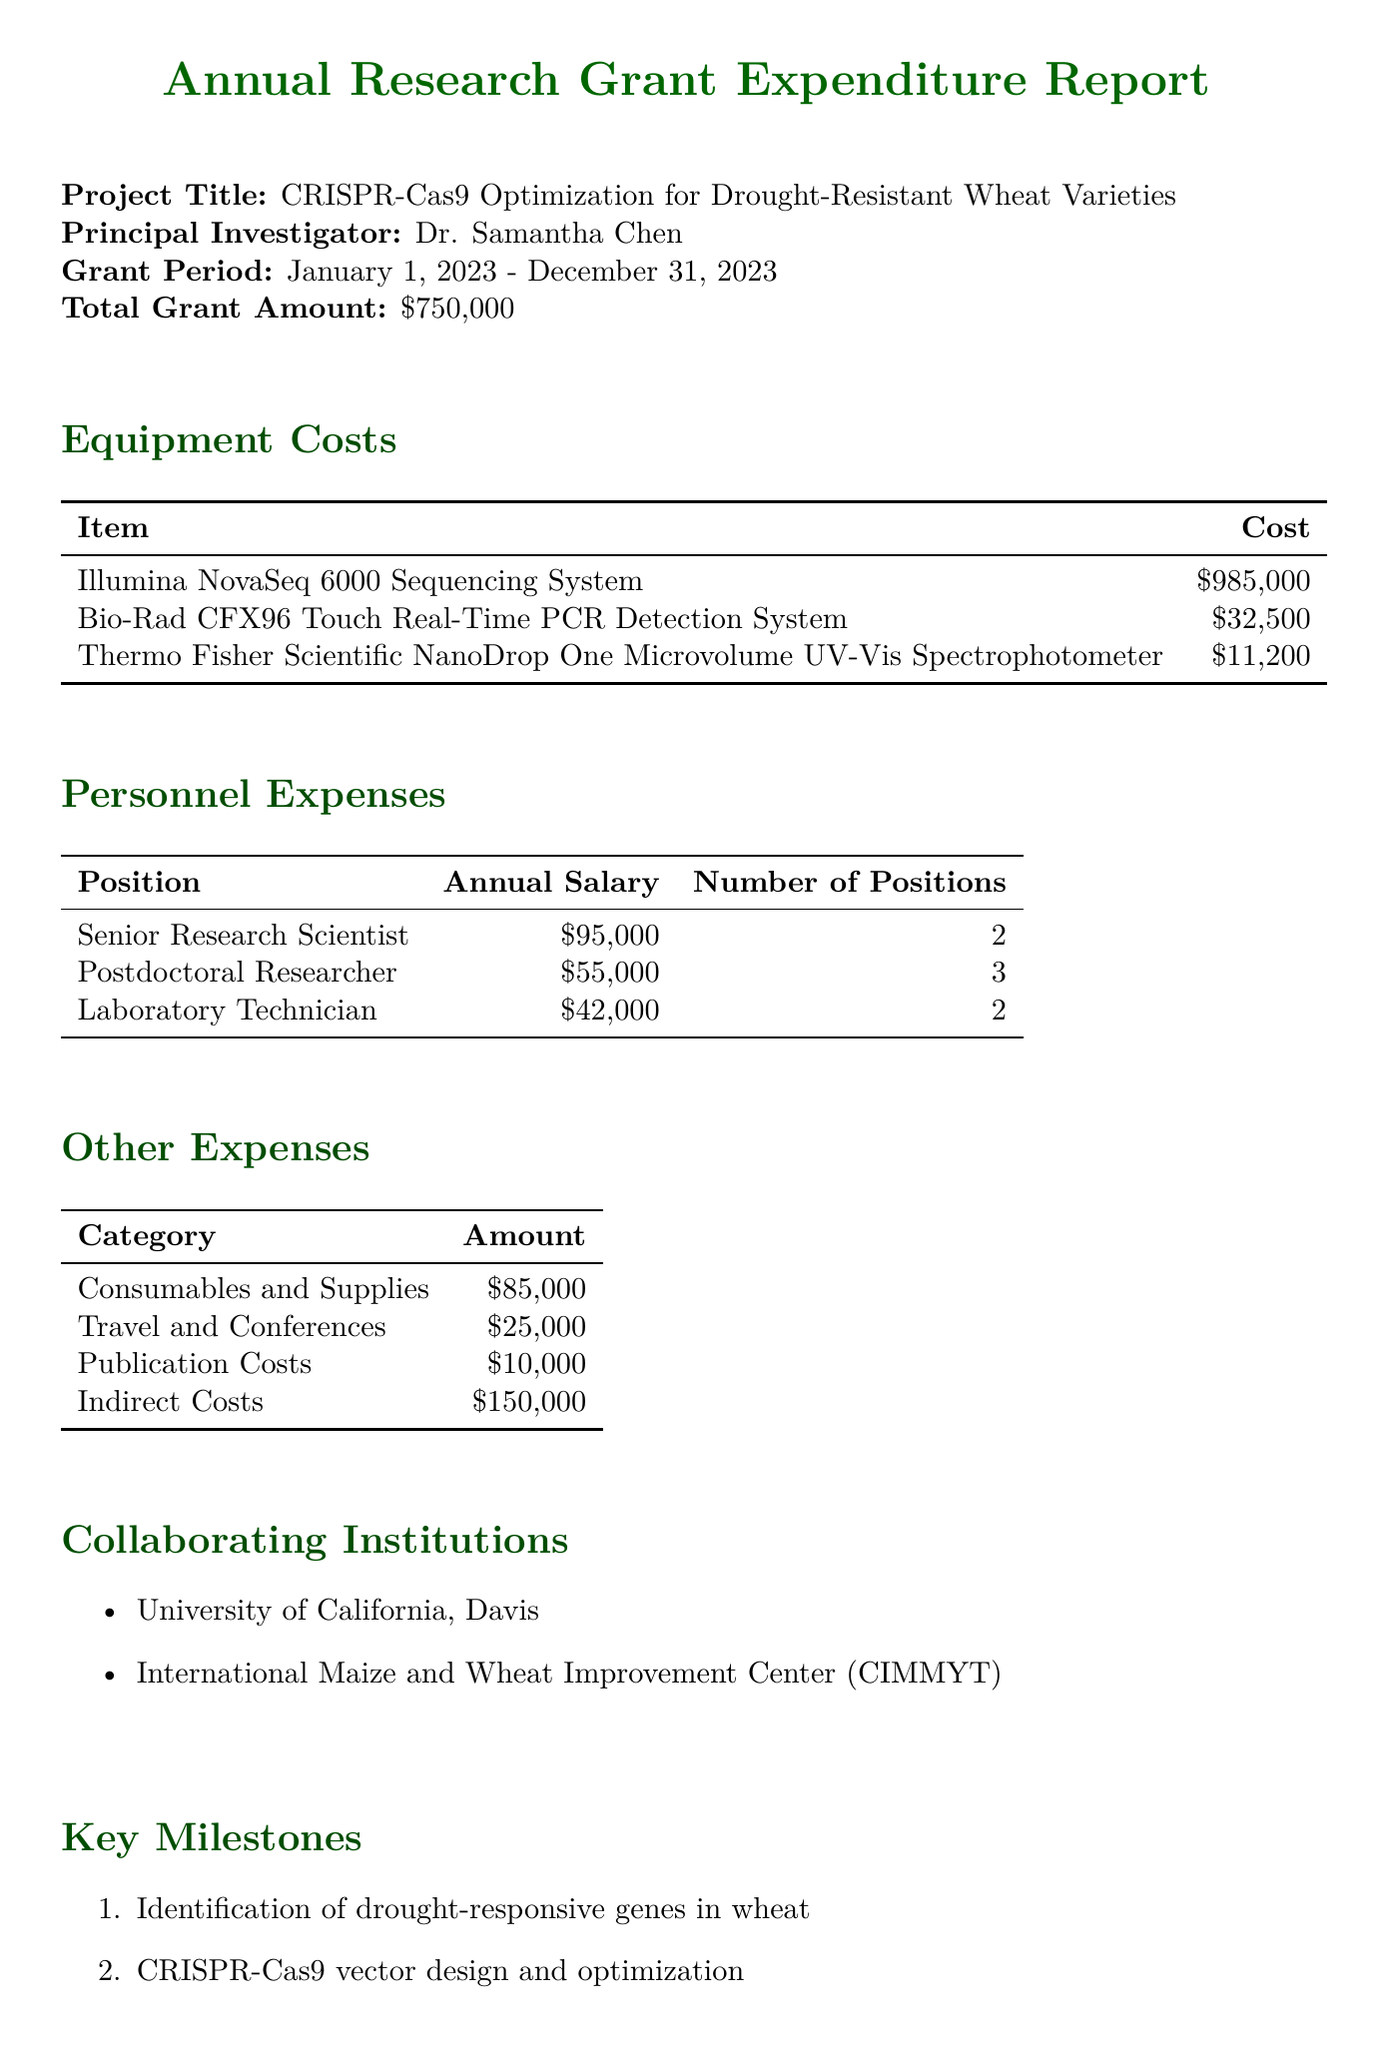What is the project title? The project title is stated at the beginning of the document and is "CRISPR-Cas9 Optimization for Drought-Resistant Wheat Varieties."
Answer: CRISPR-Cas9 Optimization for Drought-Resistant Wheat Varieties Who is the principal investigator? The principal investigator is mentioned in the document as "Dr. Samantha Chen."
Answer: Dr. Samantha Chen What is the total grant amount? The total grant amount is listed in the report as "$750,000."
Answer: $750,000 How many Senior Research Scientists are there? The personnel expenses section specifies there are "2" Senior Research Scientists.
Answer: 2 What are the indirect costs? The indirect costs are outlined in the other expenses section as "$150,000."
Answer: $150,000 What is the cost of the Illumina NovaSeq 6000 Sequencing System? The cost listed for the Illumina NovaSeq 6000 Sequencing System is "$985,000."
Answer: $985,000 What is the total number of personnel positions? The document provides the total number of personnel as 2 Senior Research Scientists, 3 Postdoctoral Researchers, and 2 Laboratory Technicians, adding up to 7 positions.
Answer: 7 Which institutions are collaborating on the project? The collaborating institutions are specifically mentioned as "University of California, Davis" and "International Maize and Wheat Improvement Center (CIMMYT)."
Answer: University of California, Davis; International Maize and Wheat Improvement Center (CIMMYT) What are the key milestones of the project? The key milestones are listed as four specific tasks including "Identification of drought-responsive genes in wheat" and others, outlining the project's progression.
Answer: Identification of drought-responsive genes in wheat, CRISPR-Cas9 vector design and optimization, Agrobacterium-mediated transformation of wheat embryos, Phenotypic analysis of T0 and T1 generations 